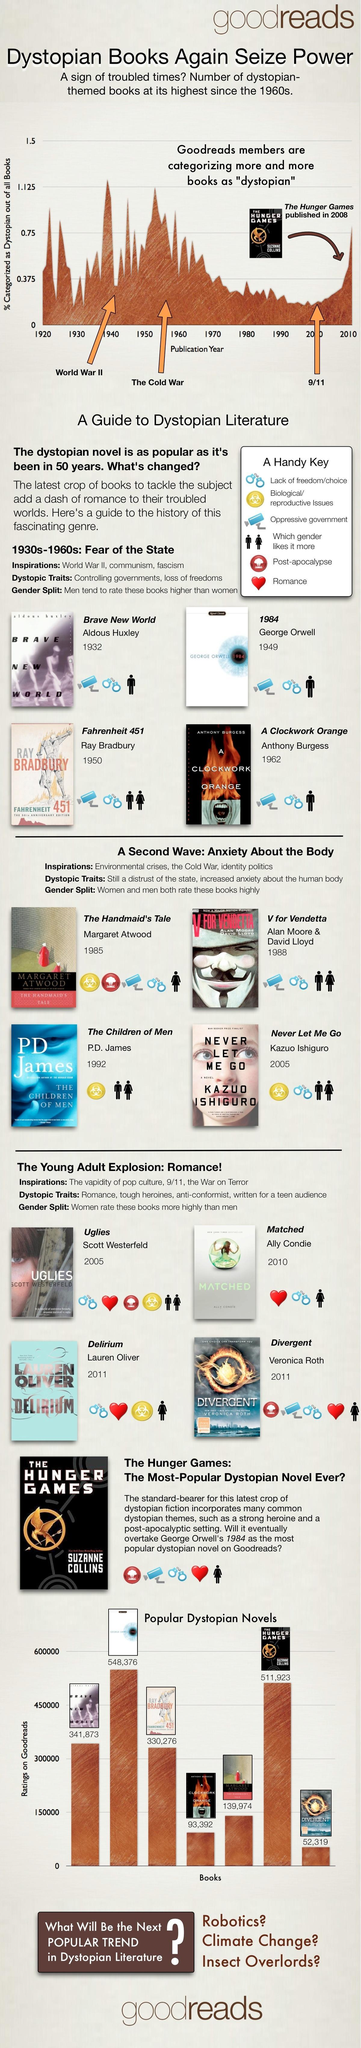Who is the author of 'Fahrenheit 451'?
Answer the question with a short phrase. Ray Bradbury Which dystopian novel has the second highest rating on Goodreads? The Hunger Games What is the rating on Goodreads for the novel ' Brave New World'? 341,873 Which dystopian novel has the highest rating on Goodreads? 1984 When was the novel titled '1984' published? 1949 Which dystopian novel has the least rating on Goodreads? Divergent Who is the author of 'Matched'? Ally Condie 